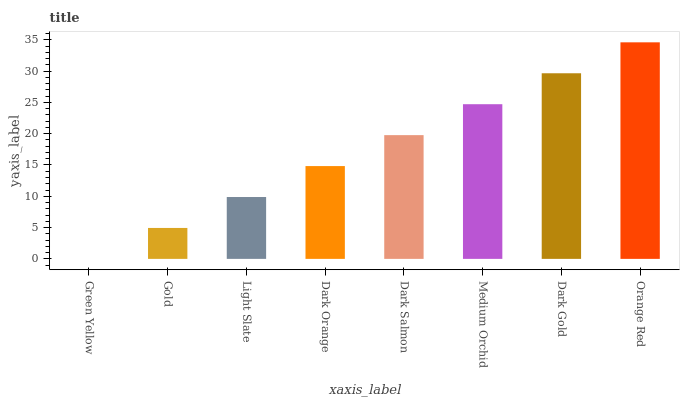Is Green Yellow the minimum?
Answer yes or no. Yes. Is Orange Red the maximum?
Answer yes or no. Yes. Is Gold the minimum?
Answer yes or no. No. Is Gold the maximum?
Answer yes or no. No. Is Gold greater than Green Yellow?
Answer yes or no. Yes. Is Green Yellow less than Gold?
Answer yes or no. Yes. Is Green Yellow greater than Gold?
Answer yes or no. No. Is Gold less than Green Yellow?
Answer yes or no. No. Is Dark Salmon the high median?
Answer yes or no. Yes. Is Dark Orange the low median?
Answer yes or no. Yes. Is Medium Orchid the high median?
Answer yes or no. No. Is Dark Gold the low median?
Answer yes or no. No. 